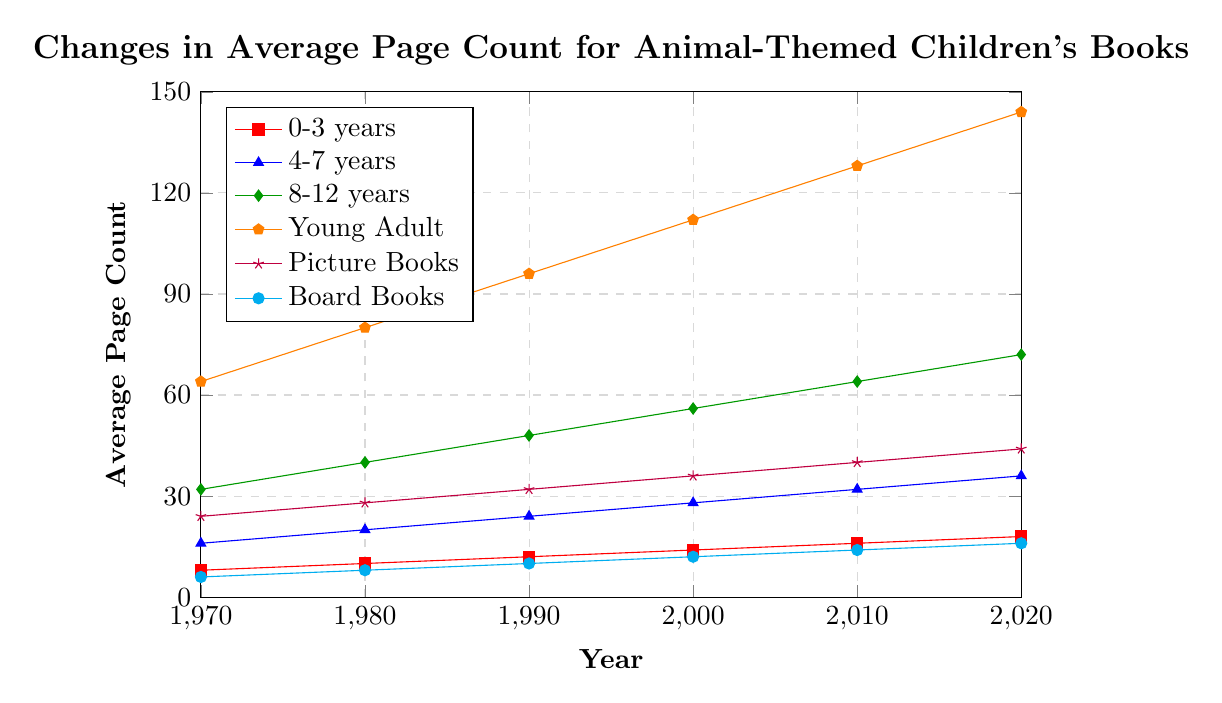Which age group saw the largest increase in average page count from 1970 to 2020? To determine the age group with the largest increase, subtract the 1970 values from the 2020 values for each group: \(10 \to 16-8=10\), \(4-7 \to 36-16=20\), \(8-12 \to 72-32=40\), \(Young Adult \to 144-64=80 \), \(Picture Books \to 44-24=20\), \(Board Books \to 16-6=10\). Clearly, the Young Adult group has the largest increase of 80 pages.
Answer: Young Adult Which age group had the smallest average page count in 2020? Look at the 2020 values for each group: \(0-3: 18\), \(4-7: 36\), \(8-12: 72\), \(Young Adult: 144\), \(Picture Books: 44\), \(Board Books: 16\). Board Books has the smallest number.
Answer: Board Books What was the difference in average page count between Picture Books and Board Books in 2000? Find the values for Picture Books and Board Books in 2000: \(Picture Books: 36, Board Books: 12\). Then, subtract \(36 - 12\): The difference is 24.
Answer: 24 Between 1990 and 2010, which age group's average page count increased by exactly 16 pages? Subtract the 1990 values from the 2010 values for each group: \(0-3 \to 16-12=4\), \(4-7 \to 32-24=8\), \(8-12 \to 64-48=16\), \(Young Adult \to 128-96=32\), \(Picture Books \to 40-32=8\), \(Board Books \to 14-10=4\). The group with exactly 16 pages increase is ages 8-12.
Answer: 8-12 years Which two age groups had an equal number of average pages in 1980? Compare the 1980 values for each group: \(0-3: 10\), \(4-7: 20\), \(8-12: 40\), \(Young Adult: 80\), \(Picture Books: 28\), \(Board Books: 8\). None of these groups have the same average page count.
Answer: None In which year did Picture Books and Board Books have their smallest difference in average page count? And what was the difference? Calculate the difference between Picture Books and Board Books for each year: 
- \(1970: 24-6=18\)
- \(1980: 28-8=20\)
- \(1990: 32-10=22\)
- \(2000: 36-12=24\)
- \(2010: 40-14=26\)
- \(2020: 44-16=28\). The smallest difference is 18 in 1970.
Answer: 1970, 18 By how much did the average page count for the age group 8-12 years increase each decade? Find increases each decade for 8-12 years: \(1980-1970=40-32=8\), \(1990-1980=48-40=8\), \(2000-1990=56-48=8\), \(2010-2000=64-56=8\), \(2020-2010=72-64=8\). The increase per decade is consistently 8 pages.
Answer: 8 pages Among all age groups in 1970, which had the highest average page count? Look at the 1970 values for each group: \(0-3: 8\), \(4-7: 16\), \(8-12: 32\), \(Young Adult: 64\), \(Picture Books: 24\), \(Board Books: 6\). Young Adult had the highest at 64 pages.
Answer: Young Adult 